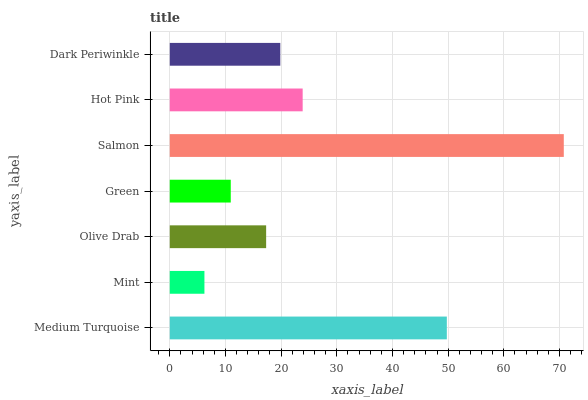Is Mint the minimum?
Answer yes or no. Yes. Is Salmon the maximum?
Answer yes or no. Yes. Is Olive Drab the minimum?
Answer yes or no. No. Is Olive Drab the maximum?
Answer yes or no. No. Is Olive Drab greater than Mint?
Answer yes or no. Yes. Is Mint less than Olive Drab?
Answer yes or no. Yes. Is Mint greater than Olive Drab?
Answer yes or no. No. Is Olive Drab less than Mint?
Answer yes or no. No. Is Dark Periwinkle the high median?
Answer yes or no. Yes. Is Dark Periwinkle the low median?
Answer yes or no. Yes. Is Salmon the high median?
Answer yes or no. No. Is Hot Pink the low median?
Answer yes or no. No. 